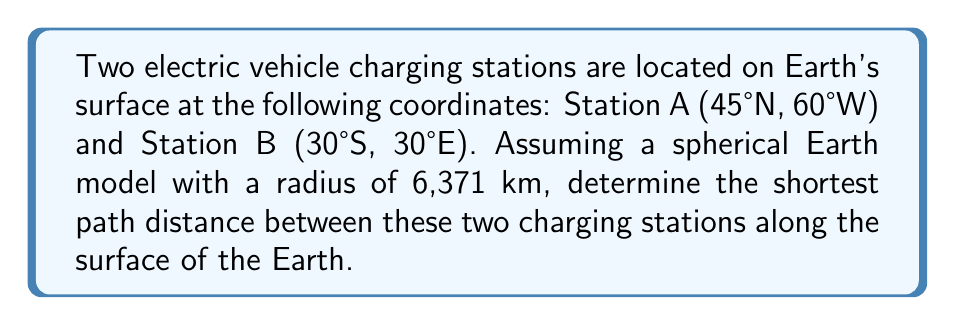Give your solution to this math problem. To solve this problem, we'll use the great circle distance formula, which gives the shortest path between two points on a sphere. The steps are as follows:

1. Convert the given coordinates to radians:
   Station A: $\phi_1 = 45° \cdot \frac{\pi}{180} = 0.7854$ rad, $\lambda_1 = -60° \cdot \frac{\pi}{180} = -1.0472$ rad
   Station B: $\phi_2 = -30° \cdot \frac{\pi}{180} = -0.5236$ rad, $\lambda_2 = 30° \cdot \frac{\pi}{180} = 0.5236$ rad

2. Calculate the central angle $\Delta\sigma$ using the Haversine formula:
   $$\Delta\sigma = 2 \arcsin\left(\sqrt{\sin^2\left(\frac{\phi_2 - \phi_1}{2}\right) + \cos\phi_1 \cos\phi_2 \sin^2\left(\frac{\lambda_2 - \lambda_1}{2}\right)}\right)$$

3. Substitute the values:
   $$\Delta\sigma = 2 \arcsin\left(\sqrt{\sin^2\left(\frac{-0.5236 - 0.7854}{2}\right) + \cos(0.7854) \cos(-0.5236) \sin^2\left(\frac{0.5236 - (-1.0472)}{2}\right)}\right)$$

4. Calculate the result:
   $$\Delta\sigma = 2 \arcsin(\sqrt{0.4239}) = 1.8064 \text{ rad}$$

5. Calculate the great circle distance $d$ by multiplying the central angle by the Earth's radius:
   $$d = R \cdot \Delta\sigma = 6371 \text{ km} \cdot 1.8064 \text{ rad} = 11,508.3 \text{ km}$$

Therefore, the shortest path distance between the two charging stations along the surface of the Earth is approximately 11,508.3 km.
Answer: 11,508.3 km 